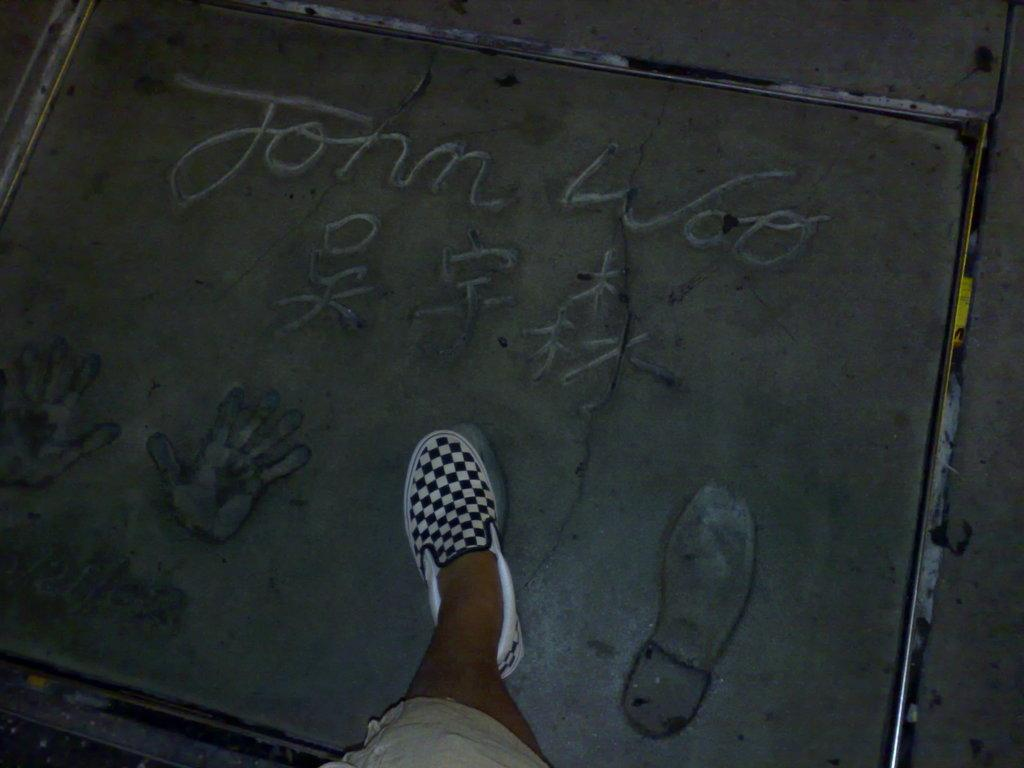Who is present in the image? There is a man in the image. What is the man doing in the image? The man is walking in the image. What is at the bottom of the image? There is a road at the bottom of the image. What color shoes is the man wearing? The man is wearing white and black color shoes. How many seeds can be seen growing on the man's shoes in the image? There are no seeds visible on the man's shoes in the image. What is the man's temper like in the image? There is no information about the man's temper in the image. 